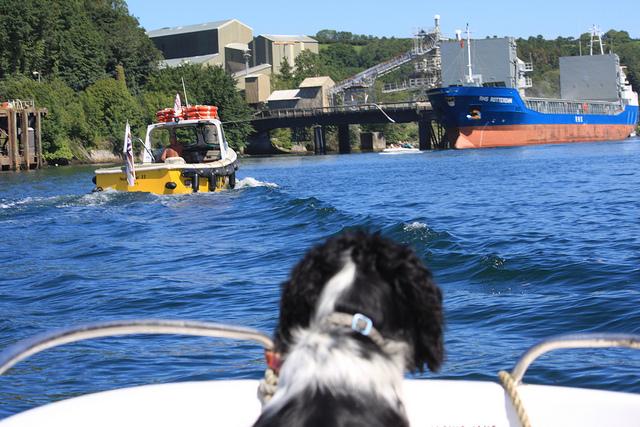What is the dog on?
Quick response, please. Boat. Where is the boat?
Keep it brief. Water. Is this dog in the water?
Keep it brief. No. 